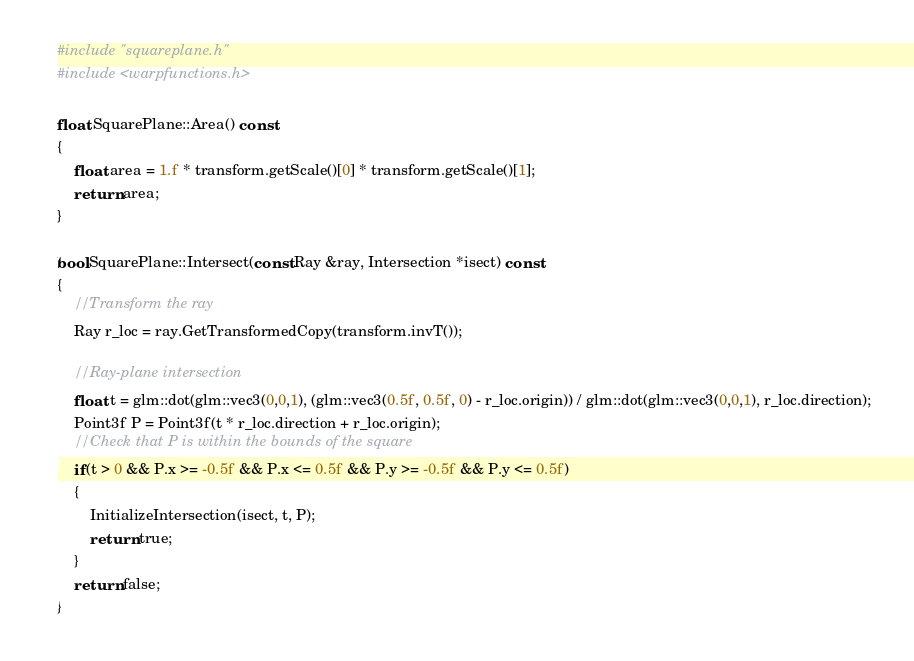<code> <loc_0><loc_0><loc_500><loc_500><_C++_>#include "squareplane.h"
#include <warpfunctions.h>

float SquarePlane::Area() const
{
    float area = 1.f * transform.getScale()[0] * transform.getScale()[1];
    return area;
}

bool SquarePlane::Intersect(const Ray &ray, Intersection *isect) const
{
    //Transform the ray
    Ray r_loc = ray.GetTransformedCopy(transform.invT());

    //Ray-plane intersection
    float t = glm::dot(glm::vec3(0,0,1), (glm::vec3(0.5f, 0.5f, 0) - r_loc.origin)) / glm::dot(glm::vec3(0,0,1), r_loc.direction);
    Point3f P = Point3f(t * r_loc.direction + r_loc.origin);
    //Check that P is within the bounds of the square
    if(t > 0 && P.x >= -0.5f && P.x <= 0.5f && P.y >= -0.5f && P.y <= 0.5f)
    {
        InitializeIntersection(isect, t, P);
        return true;
    }
    return false;
}
</code> 